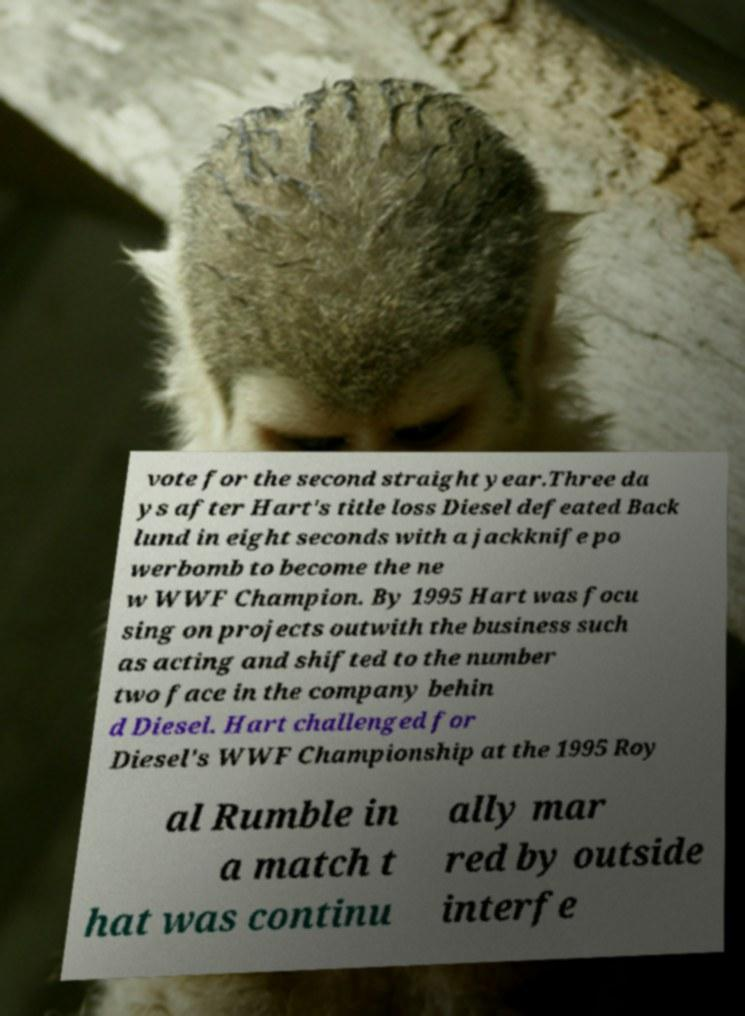Can you read and provide the text displayed in the image?This photo seems to have some interesting text. Can you extract and type it out for me? vote for the second straight year.Three da ys after Hart's title loss Diesel defeated Back lund in eight seconds with a jackknife po werbomb to become the ne w WWF Champion. By 1995 Hart was focu sing on projects outwith the business such as acting and shifted to the number two face in the company behin d Diesel. Hart challenged for Diesel's WWF Championship at the 1995 Roy al Rumble in a match t hat was continu ally mar red by outside interfe 